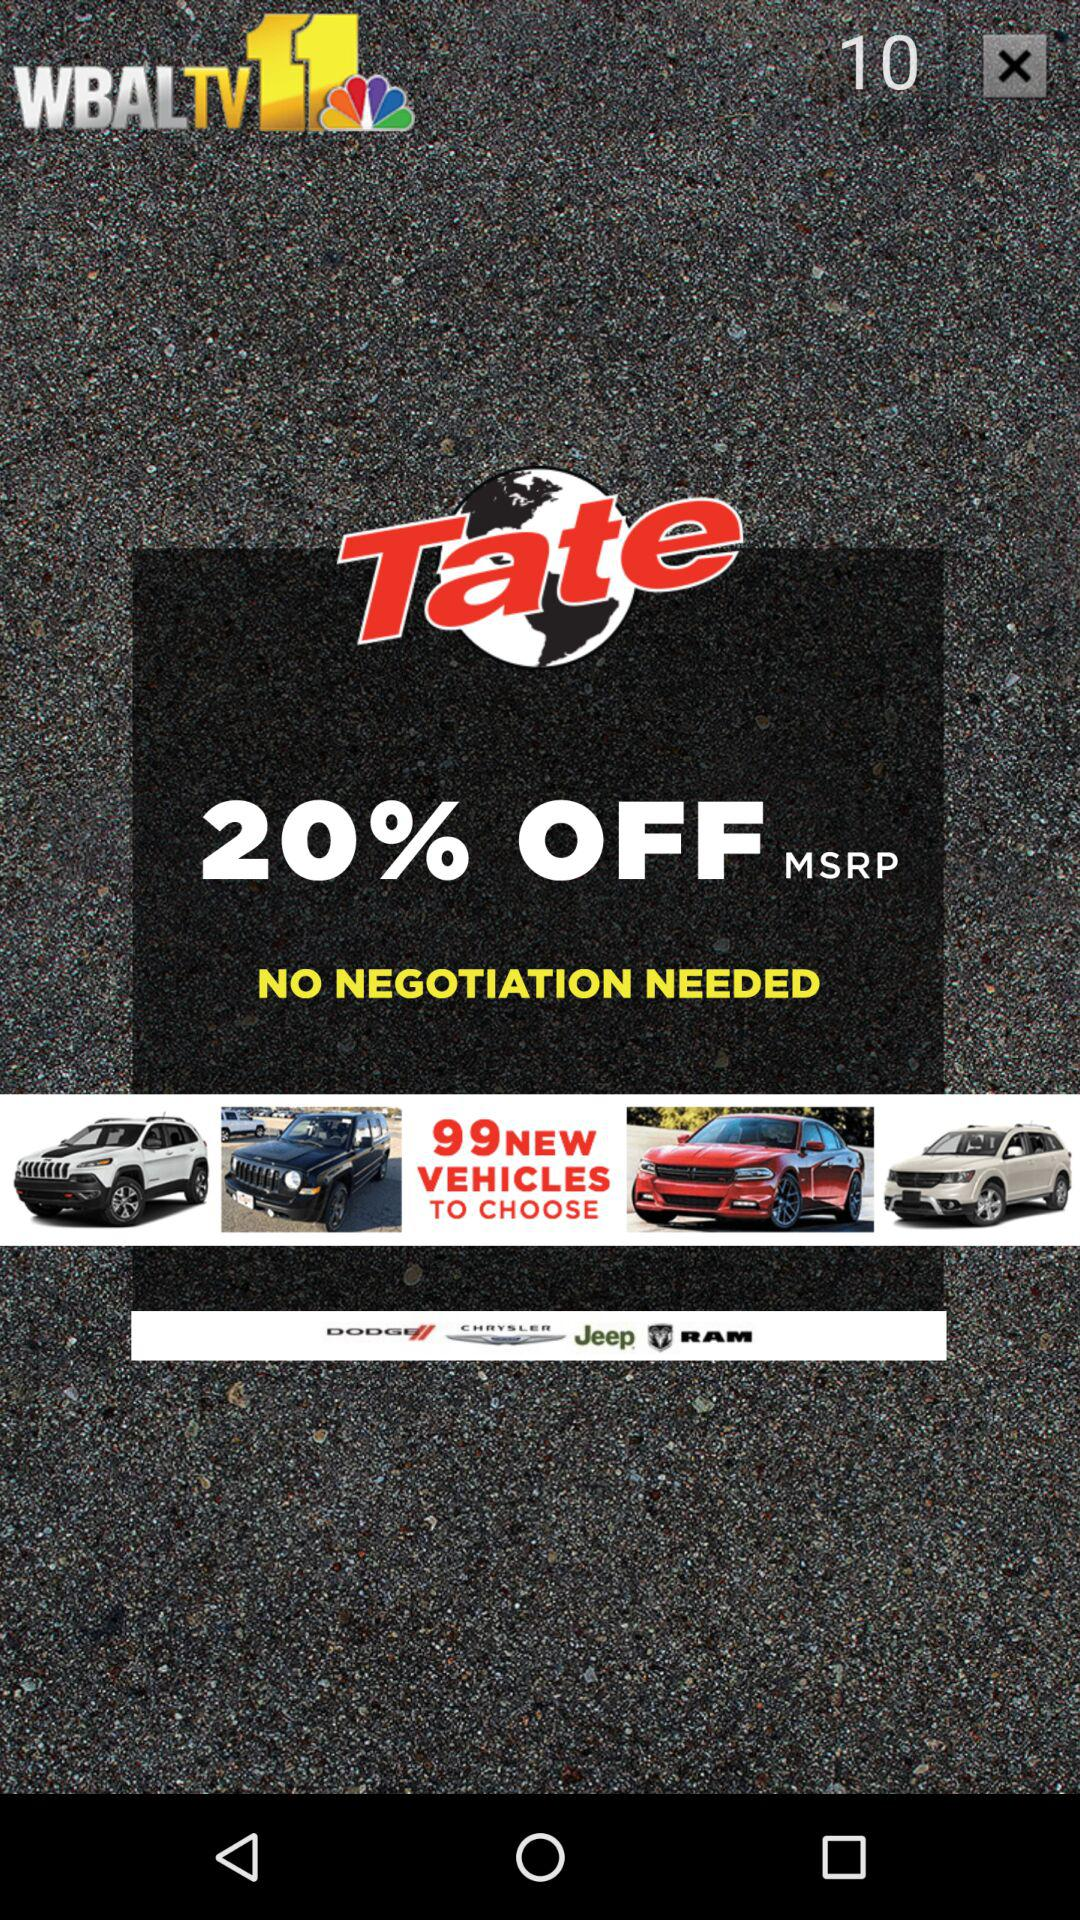How much of the discount is available? The available discount is 20% off. 